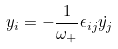<formula> <loc_0><loc_0><loc_500><loc_500>y _ { i } = - \frac { 1 } { \omega _ { + } } \epsilon _ { i j } { \dot { y _ { j } } }</formula> 